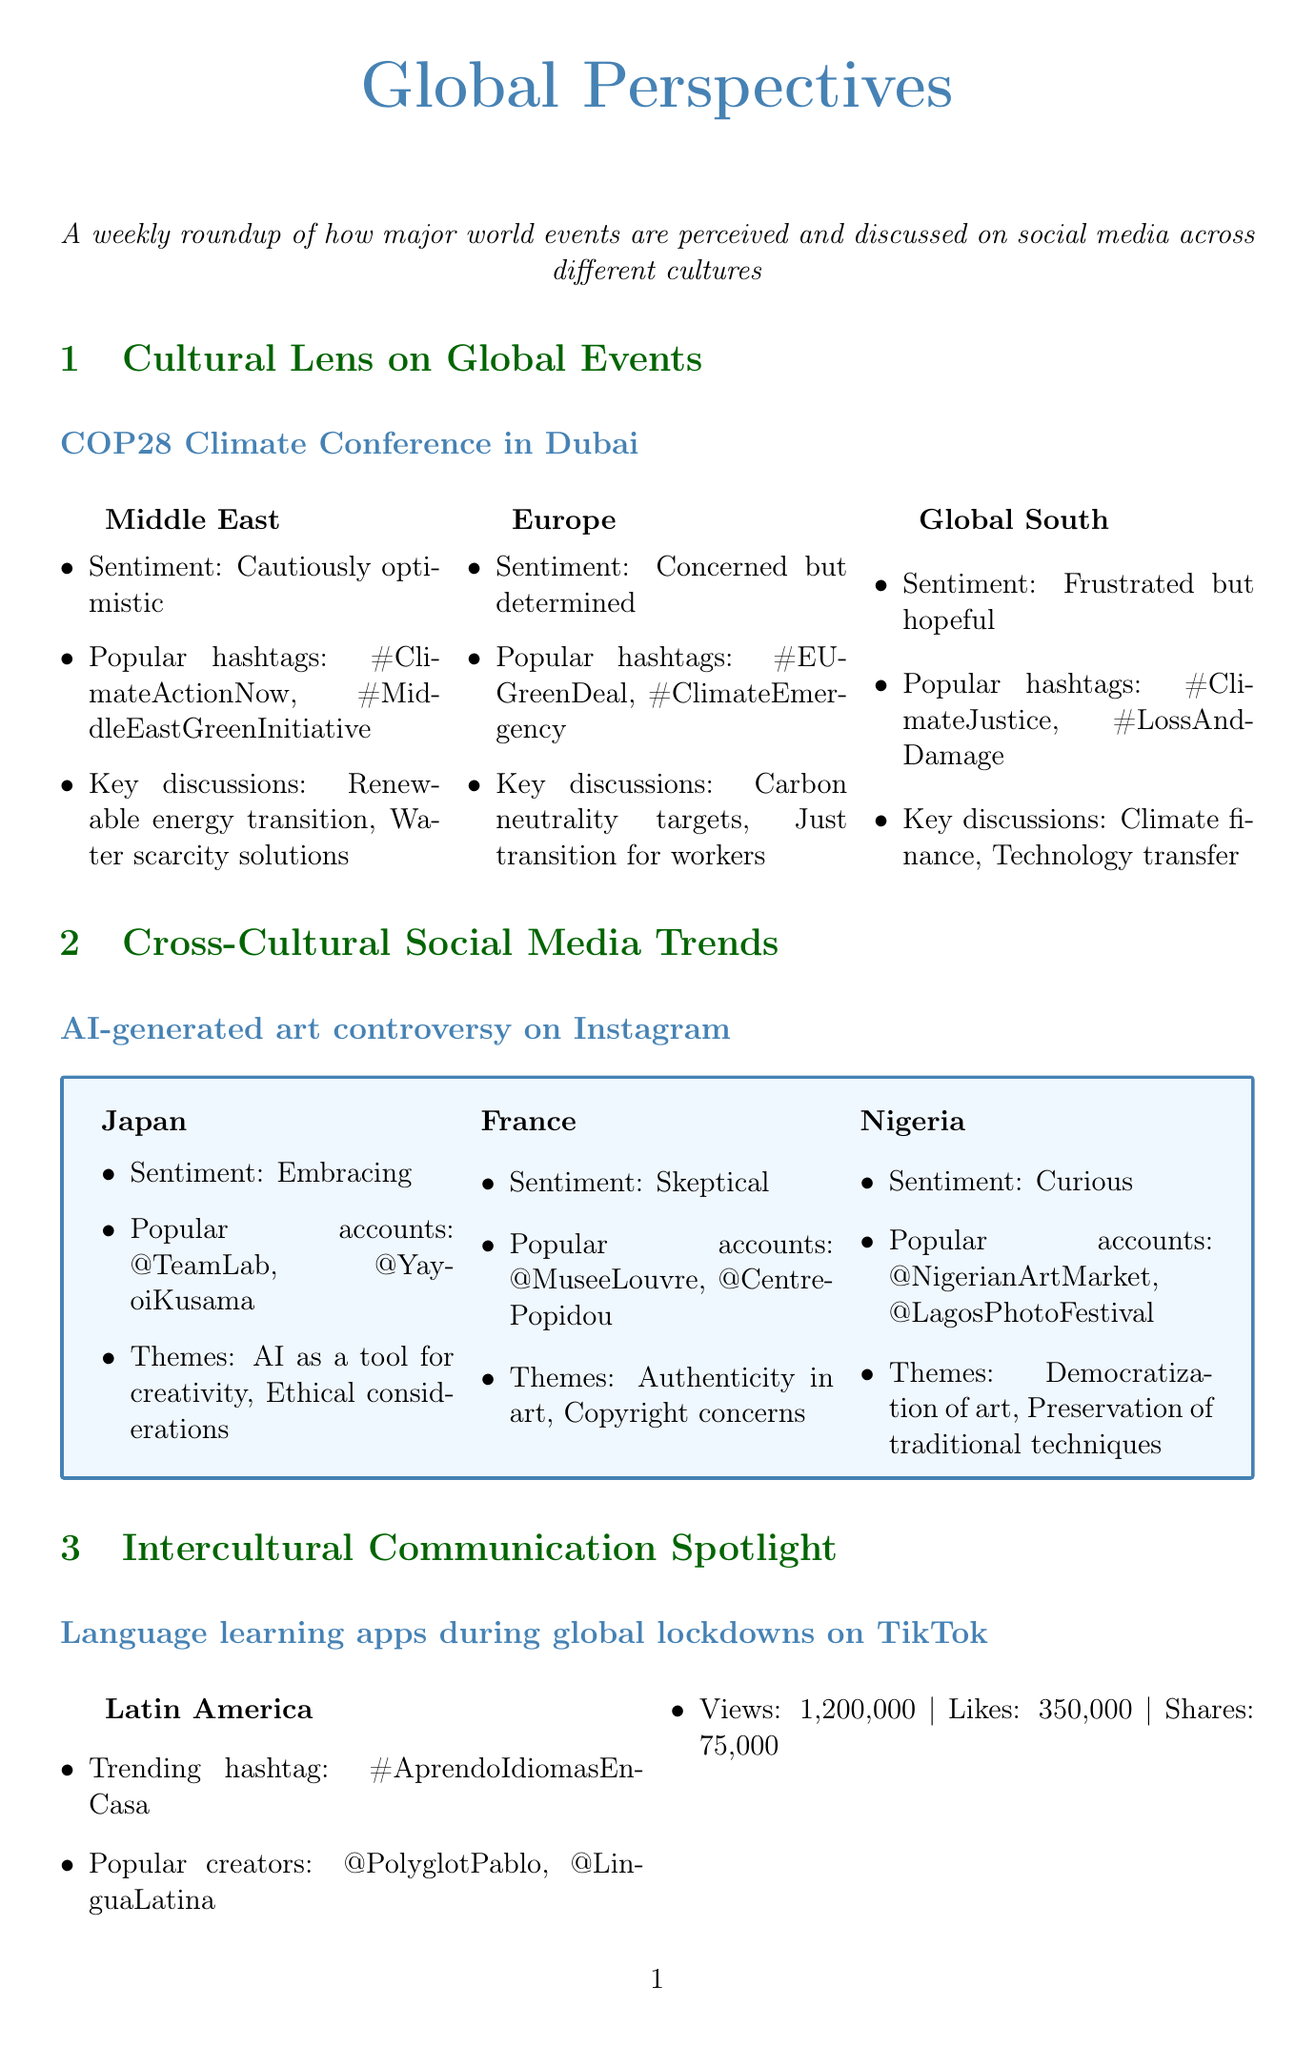What is the sentiment from the Middle East regarding COP28? The document states that the sentiment from the Middle East is "Cautiously optimistic."
Answer: Cautiously optimistic Which hashtags are popular in the Global South related to COP28? The popular hashtags mentioned for the Global South are "#ClimateJustice" and "#LossAndDamage."
Answer: #ClimateJustice, #LossAndDamage What is the trending hashtag in Latin America for language learning? The trending hashtag in Latin America is "#AprendoIdiomasEnCasa."
Answer: #AprendoIdiomasEnCasa How many views did the popular creators from Southeast Asia receive on TikTok? The views for popular creators from Southeast Asia are noted as 980,000.
Answer: 980000 What are the key discussion points for Europe at COP28? The key discussion points mentioned for Europe are "Carbon neutrality targets" and "Just transition for workers."
Answer: Carbon neutrality targets, Just transition for workers What sentiment do people in France have towards AI-generated art? The sentiment in France is described as "Skeptical."
Answer: Skeptical Which country shows a "Curious" sentiment about AI-generated art? Nigeria is identified as showing a "Curious" sentiment.
Answer: Nigeria What is a common gesture misinterpreted in video calls? The thumbs-up gesture is commonly misinterpreted.
Answer: Thumbs up What was the author’s main focus in the personal reflection section? The author's main focus was on "Navigating Cultural Nuances in Global Virtual Classrooms."
Answer: Navigating Cultural Nuances in Global Virtual Classrooms 